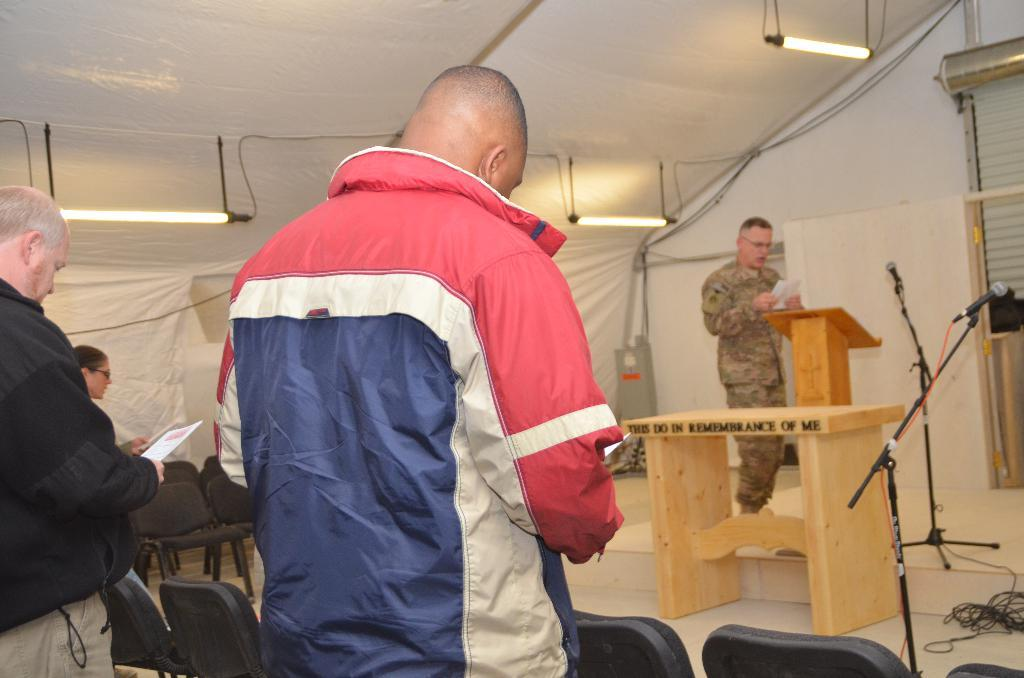What can be seen in the image? There is a group of men in the image. Where are the men located? The men are standing under a tent. What are the men holding? The men are holding papers. What type of furniture is present in the room? There are chairs and tables placed in the room. What type of stream can be heard flowing in the background of the image? There is no stream present in the image, nor is there any sound mentioned. 